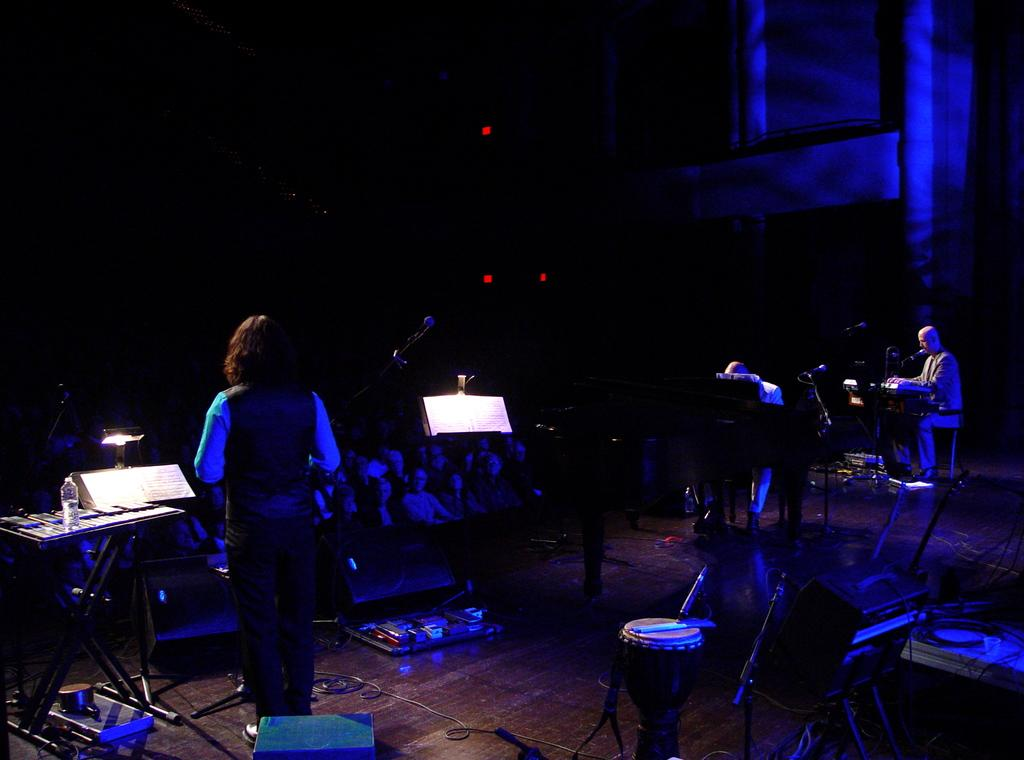What objects are present in the picture that are related to music? There are music instruments in the picture. What type of furniture can be seen in the picture? There are tables in the picture. What type of containers are visible in the picture? There are bottles in the picture. What type of illumination is present in the picture? There are lights in the picture. What type of living beings can be seen in the picture? There are people in the picture. What is the rate of air circulation in the picture? There is no information provided about the rate of air circulation in the image, as it does not involve any air-related elements. 